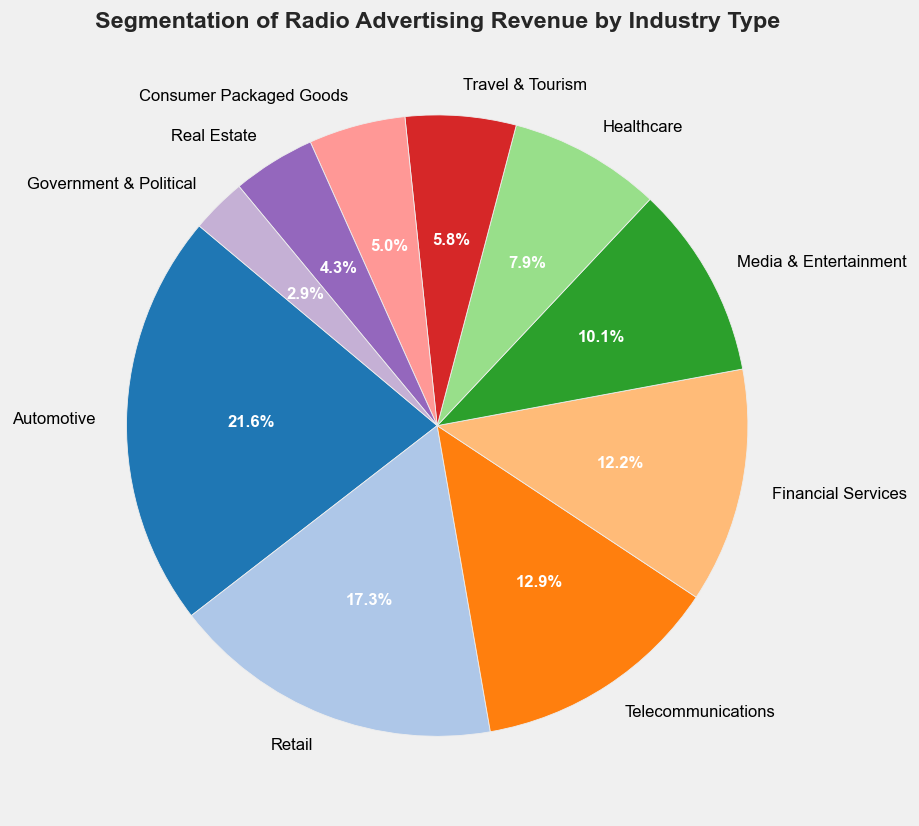What's the largest segment in the pie chart? The largest segment is represented by the wedges with the largest area, which is labeled as "Automotive" and shows the highest percentage.
Answer: Automotive What's the combined percentage of the Retail and Telecommunications industries? The Retail segment is 19.4% and the Telecommunications segment is 14.5%. Adding these two percentages together: 19.4% + 14.5% = 33.9%.
Answer: 33.9% Does Media & Entertainment or Healthcare contribute more to the radio advertising revenue? By comparing the labeled percentages on the pie chart, Media & Entertainment is 11.3%, and Healthcare is 8.9%. Since 11.3% > 8.9%, Media & Entertainment contributes more.
Answer: Media & Entertainment What is the combined revenue of Real Estate and Government & Political industries? The revenue for Real Estate is $300 million and for Government & Political is $200 million. Adding these two amounts together: $300M + $200M = $500M.
Answer: $500 million Which industry contributes the least to the radio advertising revenue? The smallest segment on the pie chart corresponds to the Government & Political industry, which is labeled with the smallest percentage.
Answer: Government & Political How much more revenue does the Automotive industry generate compared to the Consumer Packaged Goods industry? The revenue for Automotive is $1500 million and for Consumer Packaged Goods is $350 million. Subtracting the smaller value from the larger: $1500M - $350M = $1150M.
Answer: $1150 million What's the average revenue of Media & Entertainment, Travel & Tourism, and Real Estate industries? The revenue values are $700 million (Media & Entertainment), $400 million (Travel & Tourism), and $300 million (Real Estate). Summing these values gives $700M + $400M + $300M = $1400M. Dividing by 3: $1400M / 3 ≈ $466.67M.
Answer: $466.67 million Which segments are represented by shades of blue in the pie chart? By visually inspecting the pie chart for the segments colored in shades of blue, it appears that Telecommunications and Financial Services are the segments represented by shades of blue.
Answer: Telecommunications, Financial Services Is the revenue from Healthcare greater than the combined revenue from Travel & Tourism and Consumer Packaged Goods? Healthcare's revenue is $550 million. The combined revenue from Travel & Tourism and Consumer Packaged Goods is $400M + $350M = $750M. Since $550M < $750M, the revenue from Healthcare is not greater.
Answer: No 